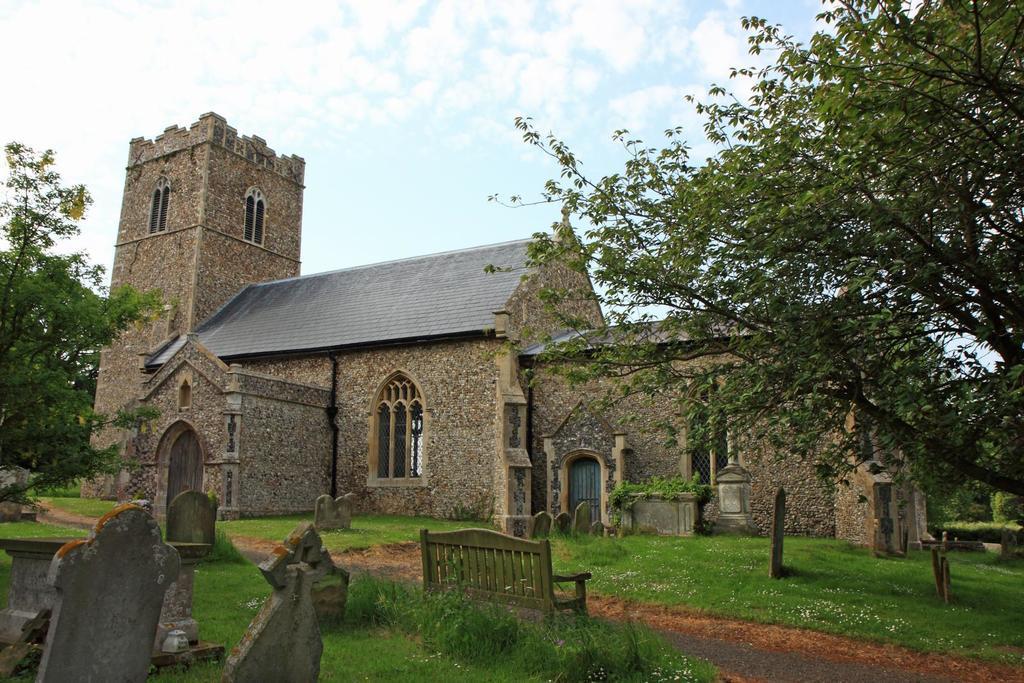Please provide a concise description of this image. In this picture I can see there is a building, walkway, there's grass on the floor. There are grave stones and there are trees at the left and right side. The sky is clear. 